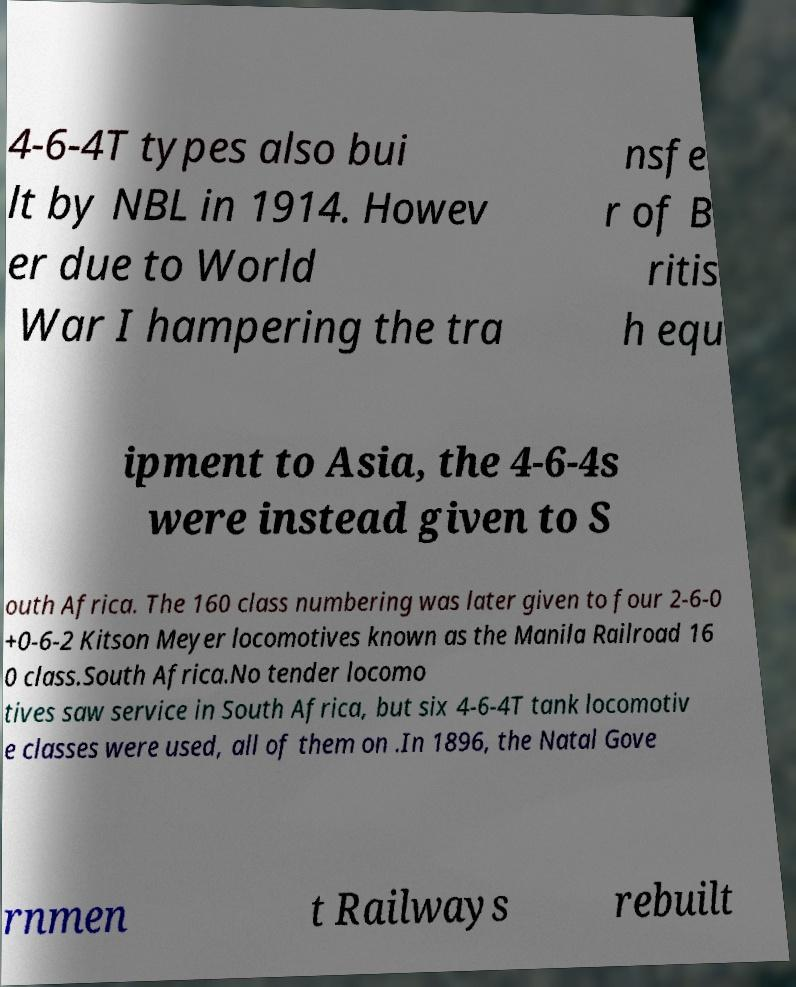There's text embedded in this image that I need extracted. Can you transcribe it verbatim? 4-6-4T types also bui lt by NBL in 1914. Howev er due to World War I hampering the tra nsfe r of B ritis h equ ipment to Asia, the 4-6-4s were instead given to S outh Africa. The 160 class numbering was later given to four 2-6-0 +0-6-2 Kitson Meyer locomotives known as the Manila Railroad 16 0 class.South Africa.No tender locomo tives saw service in South Africa, but six 4-6-4T tank locomotiv e classes were used, all of them on .In 1896, the Natal Gove rnmen t Railways rebuilt 